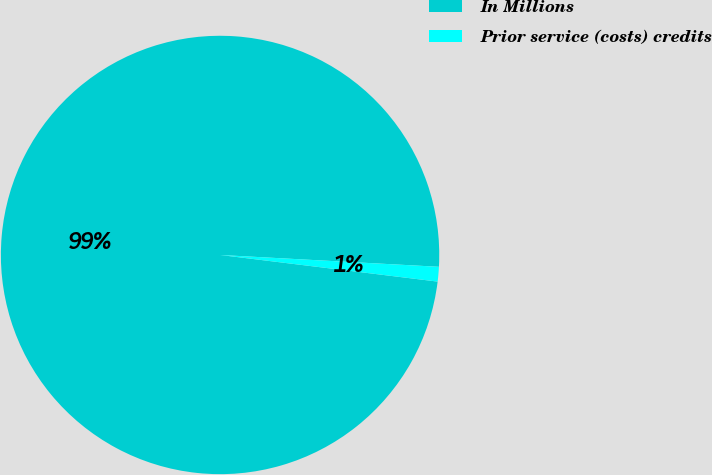Convert chart. <chart><loc_0><loc_0><loc_500><loc_500><pie_chart><fcel>In Millions<fcel>Prior service (costs) credits<nl><fcel>98.92%<fcel>1.08%<nl></chart> 